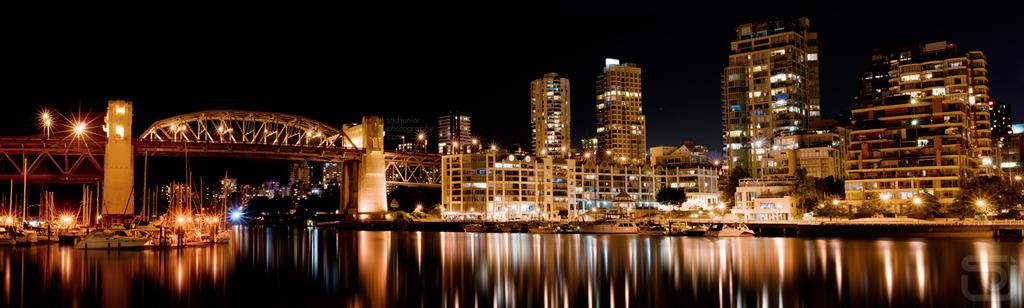What is the lighting condition in the image? The image is taken in the dark. What can be seen on the water in the image? Ships are floating on the water. What type of structure is present in the image? There is a bridge in the image. What type of buildings are visible in the image? Buildings with lights are present in the image. What type of vegetation is visible in the image? Trees are visible in the image. What is the color of the sky in the background of the image? The sky in the background is dark. What type of stone is being used to build the children's playground in the image? There is no stone or children's playground present in the image. What type of yam is being harvested in the image? There is no yam or harvesting activity present in the image. 